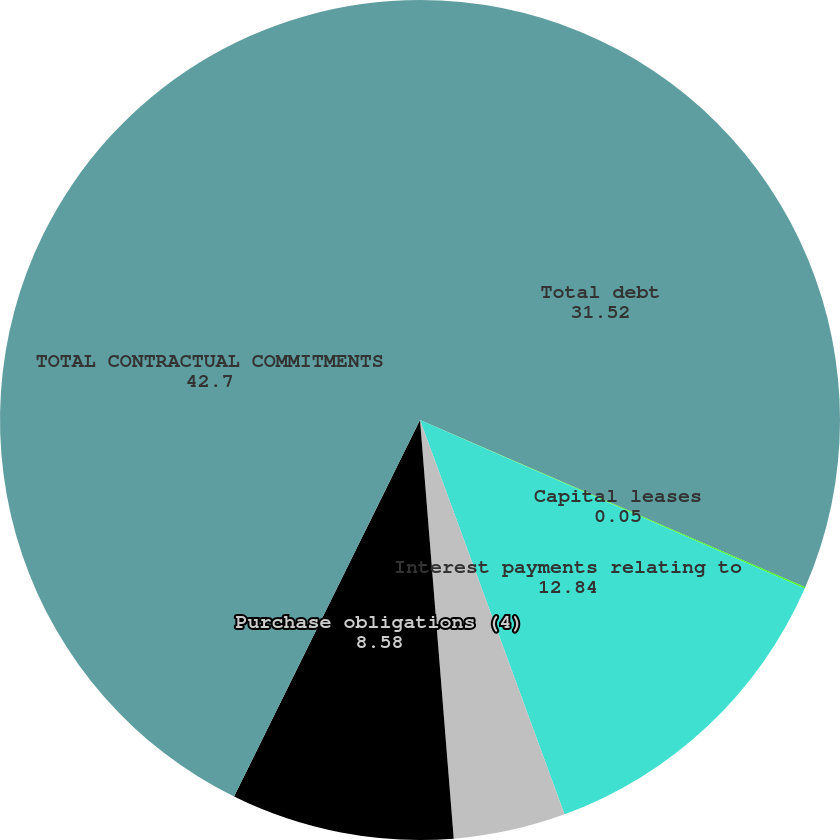Convert chart to OTSL. <chart><loc_0><loc_0><loc_500><loc_500><pie_chart><fcel>Total debt<fcel>Capital leases<fcel>Interest payments relating to<fcel>Operating leases (2)<fcel>Purchase obligations (4)<fcel>TOTAL CONTRACTUAL COMMITMENTS<nl><fcel>31.52%<fcel>0.05%<fcel>12.84%<fcel>4.31%<fcel>8.58%<fcel>42.7%<nl></chart> 